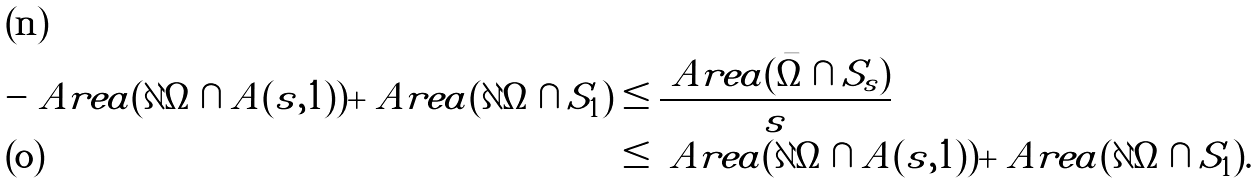Convert formula to latex. <formula><loc_0><loc_0><loc_500><loc_500>- \ A r e a ( \partial \Omega \cap A ( s , 1 ) ) + \ A r e a ( \partial { \Omega } \cap S _ { 1 } ) & \leq \frac { \ A r e a ( \bar { \Omega } \cap S _ { s } ) } { s } \\ & \leq \ A r e a ( \partial \Omega \cap A ( s , 1 ) ) + \ A r e a ( \partial { \Omega } \cap S _ { 1 } ) .</formula> 